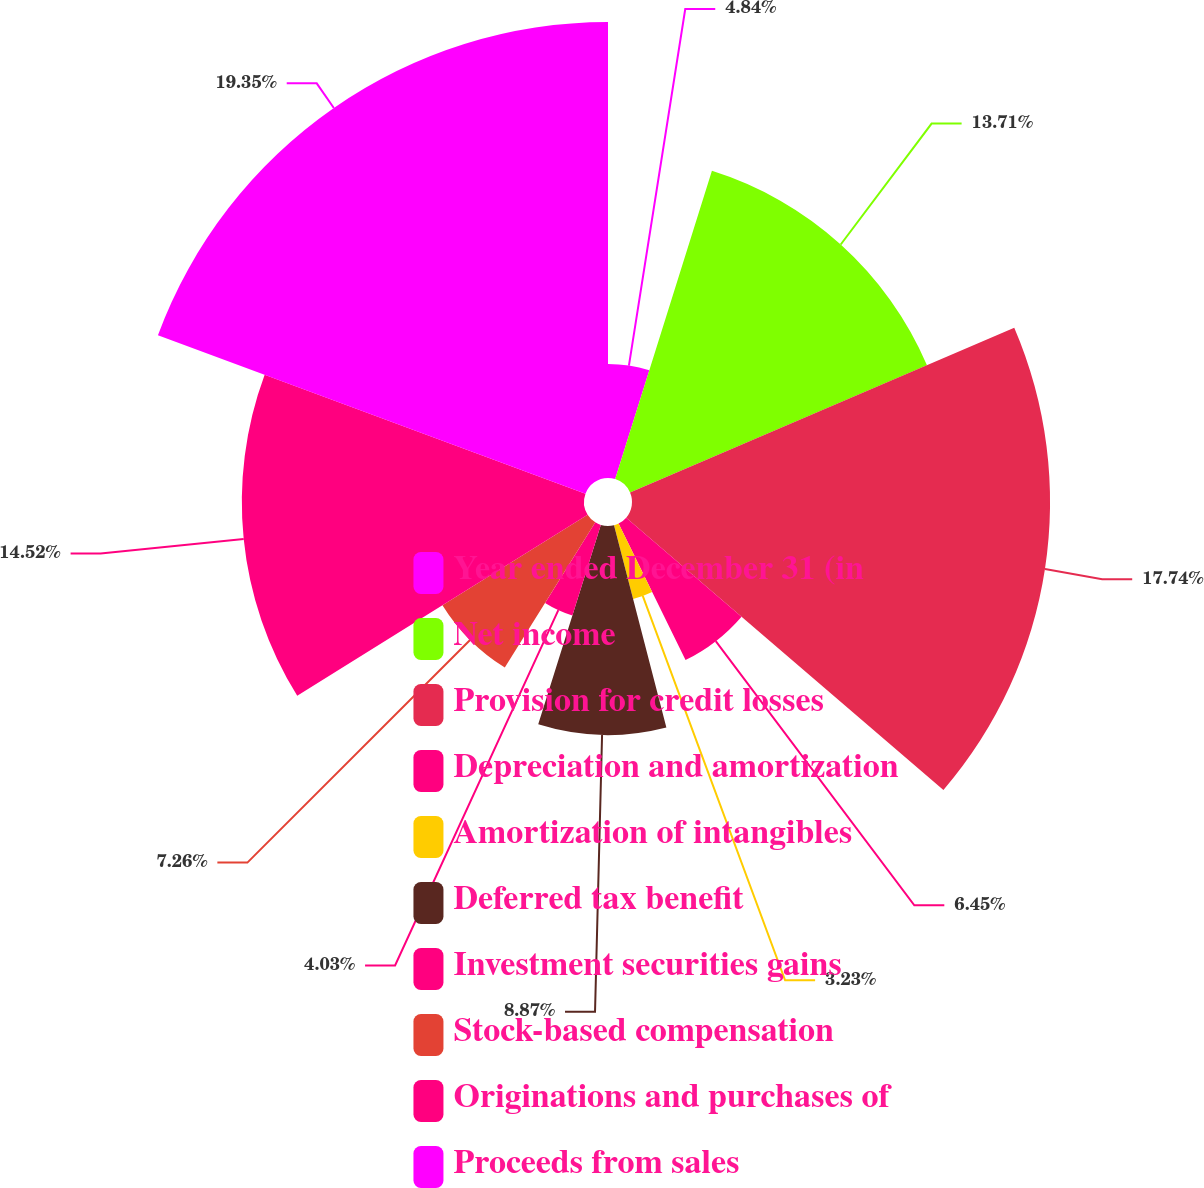<chart> <loc_0><loc_0><loc_500><loc_500><pie_chart><fcel>Year ended December 31 (in<fcel>Net income<fcel>Provision for credit losses<fcel>Depreciation and amortization<fcel>Amortization of intangibles<fcel>Deferred tax benefit<fcel>Investment securities gains<fcel>Stock-based compensation<fcel>Originations and purchases of<fcel>Proceeds from sales<nl><fcel>4.84%<fcel>13.71%<fcel>17.74%<fcel>6.45%<fcel>3.23%<fcel>8.87%<fcel>4.03%<fcel>7.26%<fcel>14.52%<fcel>19.35%<nl></chart> 